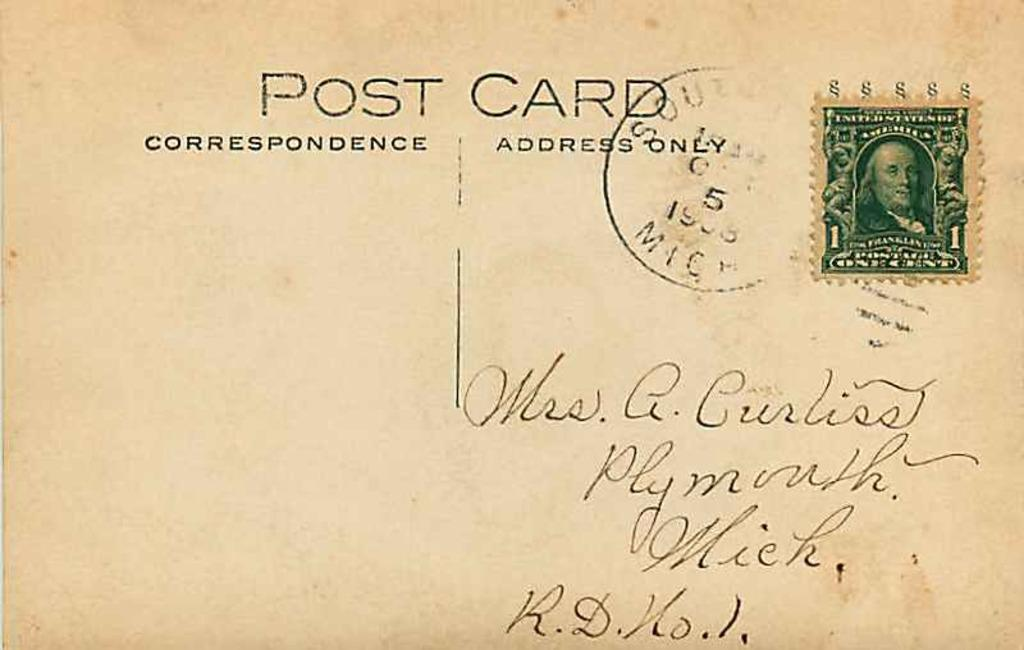<image>
Render a clear and concise summary of the photo. A postcard is addressed to someone in Michigan. 